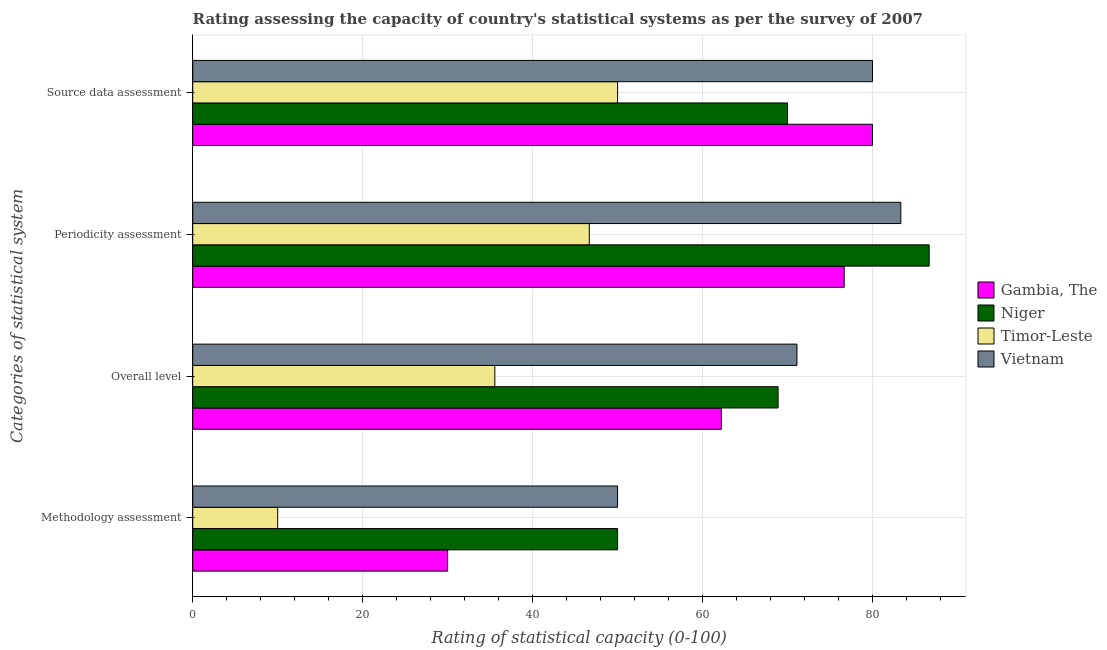How many groups of bars are there?
Your answer should be compact. 4. Are the number of bars per tick equal to the number of legend labels?
Make the answer very short. Yes. How many bars are there on the 2nd tick from the top?
Offer a terse response. 4. What is the label of the 4th group of bars from the top?
Offer a very short reply. Methodology assessment. What is the source data assessment rating in Gambia, The?
Make the answer very short. 80. Across all countries, what is the maximum source data assessment rating?
Keep it short and to the point. 80. Across all countries, what is the minimum periodicity assessment rating?
Your answer should be compact. 46.67. In which country was the methodology assessment rating maximum?
Make the answer very short. Niger. In which country was the methodology assessment rating minimum?
Your response must be concise. Timor-Leste. What is the total source data assessment rating in the graph?
Give a very brief answer. 280. What is the difference between the overall level rating in Vietnam and the source data assessment rating in Gambia, The?
Make the answer very short. -8.89. What is the average periodicity assessment rating per country?
Provide a succinct answer. 73.33. What is the difference between the periodicity assessment rating and methodology assessment rating in Vietnam?
Ensure brevity in your answer.  33.33. What is the ratio of the source data assessment rating in Niger to that in Gambia, The?
Your answer should be very brief. 0.88. Is the source data assessment rating in Vietnam less than that in Gambia, The?
Make the answer very short. No. What is the difference between the highest and the second highest methodology assessment rating?
Give a very brief answer. 0. What does the 1st bar from the top in Methodology assessment represents?
Keep it short and to the point. Vietnam. What does the 4th bar from the bottom in Overall level represents?
Make the answer very short. Vietnam. Is it the case that in every country, the sum of the methodology assessment rating and overall level rating is greater than the periodicity assessment rating?
Offer a terse response. No. Are all the bars in the graph horizontal?
Your answer should be very brief. Yes. How many countries are there in the graph?
Your answer should be compact. 4. What is the difference between two consecutive major ticks on the X-axis?
Your response must be concise. 20. Are the values on the major ticks of X-axis written in scientific E-notation?
Your answer should be very brief. No. Does the graph contain grids?
Offer a very short reply. Yes. How many legend labels are there?
Your answer should be very brief. 4. How are the legend labels stacked?
Offer a terse response. Vertical. What is the title of the graph?
Ensure brevity in your answer.  Rating assessing the capacity of country's statistical systems as per the survey of 2007 . What is the label or title of the X-axis?
Provide a succinct answer. Rating of statistical capacity (0-100). What is the label or title of the Y-axis?
Your response must be concise. Categories of statistical system. What is the Rating of statistical capacity (0-100) in Timor-Leste in Methodology assessment?
Offer a terse response. 10. What is the Rating of statistical capacity (0-100) in Gambia, The in Overall level?
Make the answer very short. 62.22. What is the Rating of statistical capacity (0-100) in Niger in Overall level?
Provide a short and direct response. 68.89. What is the Rating of statistical capacity (0-100) in Timor-Leste in Overall level?
Your answer should be compact. 35.56. What is the Rating of statistical capacity (0-100) in Vietnam in Overall level?
Give a very brief answer. 71.11. What is the Rating of statistical capacity (0-100) of Gambia, The in Periodicity assessment?
Your answer should be compact. 76.67. What is the Rating of statistical capacity (0-100) in Niger in Periodicity assessment?
Your answer should be compact. 86.67. What is the Rating of statistical capacity (0-100) of Timor-Leste in Periodicity assessment?
Offer a terse response. 46.67. What is the Rating of statistical capacity (0-100) in Vietnam in Periodicity assessment?
Your answer should be very brief. 83.33. What is the Rating of statistical capacity (0-100) in Gambia, The in Source data assessment?
Keep it short and to the point. 80. What is the Rating of statistical capacity (0-100) in Niger in Source data assessment?
Your answer should be very brief. 70. What is the Rating of statistical capacity (0-100) of Vietnam in Source data assessment?
Your answer should be compact. 80. Across all Categories of statistical system, what is the maximum Rating of statistical capacity (0-100) of Niger?
Make the answer very short. 86.67. Across all Categories of statistical system, what is the maximum Rating of statistical capacity (0-100) in Timor-Leste?
Provide a short and direct response. 50. Across all Categories of statistical system, what is the maximum Rating of statistical capacity (0-100) in Vietnam?
Give a very brief answer. 83.33. Across all Categories of statistical system, what is the minimum Rating of statistical capacity (0-100) in Gambia, The?
Offer a terse response. 30. Across all Categories of statistical system, what is the minimum Rating of statistical capacity (0-100) of Vietnam?
Offer a very short reply. 50. What is the total Rating of statistical capacity (0-100) in Gambia, The in the graph?
Make the answer very short. 248.89. What is the total Rating of statistical capacity (0-100) in Niger in the graph?
Your answer should be compact. 275.56. What is the total Rating of statistical capacity (0-100) of Timor-Leste in the graph?
Make the answer very short. 142.22. What is the total Rating of statistical capacity (0-100) in Vietnam in the graph?
Offer a very short reply. 284.44. What is the difference between the Rating of statistical capacity (0-100) in Gambia, The in Methodology assessment and that in Overall level?
Your answer should be compact. -32.22. What is the difference between the Rating of statistical capacity (0-100) of Niger in Methodology assessment and that in Overall level?
Keep it short and to the point. -18.89. What is the difference between the Rating of statistical capacity (0-100) in Timor-Leste in Methodology assessment and that in Overall level?
Your answer should be compact. -25.56. What is the difference between the Rating of statistical capacity (0-100) in Vietnam in Methodology assessment and that in Overall level?
Ensure brevity in your answer.  -21.11. What is the difference between the Rating of statistical capacity (0-100) in Gambia, The in Methodology assessment and that in Periodicity assessment?
Offer a very short reply. -46.67. What is the difference between the Rating of statistical capacity (0-100) in Niger in Methodology assessment and that in Periodicity assessment?
Ensure brevity in your answer.  -36.67. What is the difference between the Rating of statistical capacity (0-100) in Timor-Leste in Methodology assessment and that in Periodicity assessment?
Keep it short and to the point. -36.67. What is the difference between the Rating of statistical capacity (0-100) in Vietnam in Methodology assessment and that in Periodicity assessment?
Provide a short and direct response. -33.33. What is the difference between the Rating of statistical capacity (0-100) in Gambia, The in Methodology assessment and that in Source data assessment?
Provide a succinct answer. -50. What is the difference between the Rating of statistical capacity (0-100) in Timor-Leste in Methodology assessment and that in Source data assessment?
Give a very brief answer. -40. What is the difference between the Rating of statistical capacity (0-100) of Gambia, The in Overall level and that in Periodicity assessment?
Keep it short and to the point. -14.44. What is the difference between the Rating of statistical capacity (0-100) of Niger in Overall level and that in Periodicity assessment?
Provide a short and direct response. -17.78. What is the difference between the Rating of statistical capacity (0-100) in Timor-Leste in Overall level and that in Periodicity assessment?
Ensure brevity in your answer.  -11.11. What is the difference between the Rating of statistical capacity (0-100) of Vietnam in Overall level and that in Periodicity assessment?
Your answer should be very brief. -12.22. What is the difference between the Rating of statistical capacity (0-100) in Gambia, The in Overall level and that in Source data assessment?
Make the answer very short. -17.78. What is the difference between the Rating of statistical capacity (0-100) of Niger in Overall level and that in Source data assessment?
Give a very brief answer. -1.11. What is the difference between the Rating of statistical capacity (0-100) of Timor-Leste in Overall level and that in Source data assessment?
Your answer should be compact. -14.44. What is the difference between the Rating of statistical capacity (0-100) in Vietnam in Overall level and that in Source data assessment?
Keep it short and to the point. -8.89. What is the difference between the Rating of statistical capacity (0-100) in Niger in Periodicity assessment and that in Source data assessment?
Provide a short and direct response. 16.67. What is the difference between the Rating of statistical capacity (0-100) in Timor-Leste in Periodicity assessment and that in Source data assessment?
Provide a short and direct response. -3.33. What is the difference between the Rating of statistical capacity (0-100) of Vietnam in Periodicity assessment and that in Source data assessment?
Your answer should be very brief. 3.33. What is the difference between the Rating of statistical capacity (0-100) in Gambia, The in Methodology assessment and the Rating of statistical capacity (0-100) in Niger in Overall level?
Your answer should be compact. -38.89. What is the difference between the Rating of statistical capacity (0-100) of Gambia, The in Methodology assessment and the Rating of statistical capacity (0-100) of Timor-Leste in Overall level?
Offer a very short reply. -5.56. What is the difference between the Rating of statistical capacity (0-100) of Gambia, The in Methodology assessment and the Rating of statistical capacity (0-100) of Vietnam in Overall level?
Provide a succinct answer. -41.11. What is the difference between the Rating of statistical capacity (0-100) in Niger in Methodology assessment and the Rating of statistical capacity (0-100) in Timor-Leste in Overall level?
Provide a succinct answer. 14.44. What is the difference between the Rating of statistical capacity (0-100) of Niger in Methodology assessment and the Rating of statistical capacity (0-100) of Vietnam in Overall level?
Keep it short and to the point. -21.11. What is the difference between the Rating of statistical capacity (0-100) of Timor-Leste in Methodology assessment and the Rating of statistical capacity (0-100) of Vietnam in Overall level?
Provide a short and direct response. -61.11. What is the difference between the Rating of statistical capacity (0-100) in Gambia, The in Methodology assessment and the Rating of statistical capacity (0-100) in Niger in Periodicity assessment?
Ensure brevity in your answer.  -56.67. What is the difference between the Rating of statistical capacity (0-100) in Gambia, The in Methodology assessment and the Rating of statistical capacity (0-100) in Timor-Leste in Periodicity assessment?
Provide a short and direct response. -16.67. What is the difference between the Rating of statistical capacity (0-100) of Gambia, The in Methodology assessment and the Rating of statistical capacity (0-100) of Vietnam in Periodicity assessment?
Your response must be concise. -53.33. What is the difference between the Rating of statistical capacity (0-100) in Niger in Methodology assessment and the Rating of statistical capacity (0-100) in Timor-Leste in Periodicity assessment?
Make the answer very short. 3.33. What is the difference between the Rating of statistical capacity (0-100) in Niger in Methodology assessment and the Rating of statistical capacity (0-100) in Vietnam in Periodicity assessment?
Make the answer very short. -33.33. What is the difference between the Rating of statistical capacity (0-100) of Timor-Leste in Methodology assessment and the Rating of statistical capacity (0-100) of Vietnam in Periodicity assessment?
Offer a very short reply. -73.33. What is the difference between the Rating of statistical capacity (0-100) of Gambia, The in Methodology assessment and the Rating of statistical capacity (0-100) of Niger in Source data assessment?
Provide a short and direct response. -40. What is the difference between the Rating of statistical capacity (0-100) of Gambia, The in Methodology assessment and the Rating of statistical capacity (0-100) of Vietnam in Source data assessment?
Keep it short and to the point. -50. What is the difference between the Rating of statistical capacity (0-100) of Timor-Leste in Methodology assessment and the Rating of statistical capacity (0-100) of Vietnam in Source data assessment?
Make the answer very short. -70. What is the difference between the Rating of statistical capacity (0-100) of Gambia, The in Overall level and the Rating of statistical capacity (0-100) of Niger in Periodicity assessment?
Ensure brevity in your answer.  -24.44. What is the difference between the Rating of statistical capacity (0-100) in Gambia, The in Overall level and the Rating of statistical capacity (0-100) in Timor-Leste in Periodicity assessment?
Your response must be concise. 15.56. What is the difference between the Rating of statistical capacity (0-100) of Gambia, The in Overall level and the Rating of statistical capacity (0-100) of Vietnam in Periodicity assessment?
Provide a short and direct response. -21.11. What is the difference between the Rating of statistical capacity (0-100) of Niger in Overall level and the Rating of statistical capacity (0-100) of Timor-Leste in Periodicity assessment?
Offer a terse response. 22.22. What is the difference between the Rating of statistical capacity (0-100) in Niger in Overall level and the Rating of statistical capacity (0-100) in Vietnam in Periodicity assessment?
Give a very brief answer. -14.44. What is the difference between the Rating of statistical capacity (0-100) in Timor-Leste in Overall level and the Rating of statistical capacity (0-100) in Vietnam in Periodicity assessment?
Give a very brief answer. -47.78. What is the difference between the Rating of statistical capacity (0-100) of Gambia, The in Overall level and the Rating of statistical capacity (0-100) of Niger in Source data assessment?
Ensure brevity in your answer.  -7.78. What is the difference between the Rating of statistical capacity (0-100) of Gambia, The in Overall level and the Rating of statistical capacity (0-100) of Timor-Leste in Source data assessment?
Your answer should be compact. 12.22. What is the difference between the Rating of statistical capacity (0-100) of Gambia, The in Overall level and the Rating of statistical capacity (0-100) of Vietnam in Source data assessment?
Offer a terse response. -17.78. What is the difference between the Rating of statistical capacity (0-100) of Niger in Overall level and the Rating of statistical capacity (0-100) of Timor-Leste in Source data assessment?
Your answer should be very brief. 18.89. What is the difference between the Rating of statistical capacity (0-100) in Niger in Overall level and the Rating of statistical capacity (0-100) in Vietnam in Source data assessment?
Offer a very short reply. -11.11. What is the difference between the Rating of statistical capacity (0-100) of Timor-Leste in Overall level and the Rating of statistical capacity (0-100) of Vietnam in Source data assessment?
Your answer should be very brief. -44.44. What is the difference between the Rating of statistical capacity (0-100) in Gambia, The in Periodicity assessment and the Rating of statistical capacity (0-100) in Niger in Source data assessment?
Your response must be concise. 6.67. What is the difference between the Rating of statistical capacity (0-100) of Gambia, The in Periodicity assessment and the Rating of statistical capacity (0-100) of Timor-Leste in Source data assessment?
Ensure brevity in your answer.  26.67. What is the difference between the Rating of statistical capacity (0-100) of Gambia, The in Periodicity assessment and the Rating of statistical capacity (0-100) of Vietnam in Source data assessment?
Offer a terse response. -3.33. What is the difference between the Rating of statistical capacity (0-100) of Niger in Periodicity assessment and the Rating of statistical capacity (0-100) of Timor-Leste in Source data assessment?
Your response must be concise. 36.67. What is the difference between the Rating of statistical capacity (0-100) in Niger in Periodicity assessment and the Rating of statistical capacity (0-100) in Vietnam in Source data assessment?
Your answer should be compact. 6.67. What is the difference between the Rating of statistical capacity (0-100) of Timor-Leste in Periodicity assessment and the Rating of statistical capacity (0-100) of Vietnam in Source data assessment?
Your answer should be very brief. -33.33. What is the average Rating of statistical capacity (0-100) of Gambia, The per Categories of statistical system?
Offer a very short reply. 62.22. What is the average Rating of statistical capacity (0-100) in Niger per Categories of statistical system?
Your answer should be very brief. 68.89. What is the average Rating of statistical capacity (0-100) of Timor-Leste per Categories of statistical system?
Provide a succinct answer. 35.56. What is the average Rating of statistical capacity (0-100) in Vietnam per Categories of statistical system?
Offer a very short reply. 71.11. What is the difference between the Rating of statistical capacity (0-100) of Gambia, The and Rating of statistical capacity (0-100) of Niger in Methodology assessment?
Give a very brief answer. -20. What is the difference between the Rating of statistical capacity (0-100) in Gambia, The and Rating of statistical capacity (0-100) in Timor-Leste in Methodology assessment?
Provide a succinct answer. 20. What is the difference between the Rating of statistical capacity (0-100) of Niger and Rating of statistical capacity (0-100) of Timor-Leste in Methodology assessment?
Offer a very short reply. 40. What is the difference between the Rating of statistical capacity (0-100) of Timor-Leste and Rating of statistical capacity (0-100) of Vietnam in Methodology assessment?
Offer a terse response. -40. What is the difference between the Rating of statistical capacity (0-100) in Gambia, The and Rating of statistical capacity (0-100) in Niger in Overall level?
Keep it short and to the point. -6.67. What is the difference between the Rating of statistical capacity (0-100) in Gambia, The and Rating of statistical capacity (0-100) in Timor-Leste in Overall level?
Ensure brevity in your answer.  26.67. What is the difference between the Rating of statistical capacity (0-100) in Gambia, The and Rating of statistical capacity (0-100) in Vietnam in Overall level?
Your answer should be very brief. -8.89. What is the difference between the Rating of statistical capacity (0-100) of Niger and Rating of statistical capacity (0-100) of Timor-Leste in Overall level?
Offer a very short reply. 33.33. What is the difference between the Rating of statistical capacity (0-100) of Niger and Rating of statistical capacity (0-100) of Vietnam in Overall level?
Your answer should be compact. -2.22. What is the difference between the Rating of statistical capacity (0-100) of Timor-Leste and Rating of statistical capacity (0-100) of Vietnam in Overall level?
Provide a succinct answer. -35.56. What is the difference between the Rating of statistical capacity (0-100) in Gambia, The and Rating of statistical capacity (0-100) in Vietnam in Periodicity assessment?
Your answer should be compact. -6.67. What is the difference between the Rating of statistical capacity (0-100) in Niger and Rating of statistical capacity (0-100) in Timor-Leste in Periodicity assessment?
Give a very brief answer. 40. What is the difference between the Rating of statistical capacity (0-100) of Timor-Leste and Rating of statistical capacity (0-100) of Vietnam in Periodicity assessment?
Offer a very short reply. -36.67. What is the difference between the Rating of statistical capacity (0-100) of Gambia, The and Rating of statistical capacity (0-100) of Timor-Leste in Source data assessment?
Keep it short and to the point. 30. What is the difference between the Rating of statistical capacity (0-100) in Niger and Rating of statistical capacity (0-100) in Timor-Leste in Source data assessment?
Give a very brief answer. 20. What is the ratio of the Rating of statistical capacity (0-100) in Gambia, The in Methodology assessment to that in Overall level?
Your response must be concise. 0.48. What is the ratio of the Rating of statistical capacity (0-100) in Niger in Methodology assessment to that in Overall level?
Your answer should be very brief. 0.73. What is the ratio of the Rating of statistical capacity (0-100) in Timor-Leste in Methodology assessment to that in Overall level?
Your answer should be very brief. 0.28. What is the ratio of the Rating of statistical capacity (0-100) in Vietnam in Methodology assessment to that in Overall level?
Provide a succinct answer. 0.7. What is the ratio of the Rating of statistical capacity (0-100) of Gambia, The in Methodology assessment to that in Periodicity assessment?
Ensure brevity in your answer.  0.39. What is the ratio of the Rating of statistical capacity (0-100) in Niger in Methodology assessment to that in Periodicity assessment?
Offer a terse response. 0.58. What is the ratio of the Rating of statistical capacity (0-100) of Timor-Leste in Methodology assessment to that in Periodicity assessment?
Your answer should be very brief. 0.21. What is the ratio of the Rating of statistical capacity (0-100) of Niger in Methodology assessment to that in Source data assessment?
Give a very brief answer. 0.71. What is the ratio of the Rating of statistical capacity (0-100) in Gambia, The in Overall level to that in Periodicity assessment?
Keep it short and to the point. 0.81. What is the ratio of the Rating of statistical capacity (0-100) of Niger in Overall level to that in Periodicity assessment?
Your answer should be compact. 0.79. What is the ratio of the Rating of statistical capacity (0-100) in Timor-Leste in Overall level to that in Periodicity assessment?
Provide a succinct answer. 0.76. What is the ratio of the Rating of statistical capacity (0-100) in Vietnam in Overall level to that in Periodicity assessment?
Make the answer very short. 0.85. What is the ratio of the Rating of statistical capacity (0-100) in Niger in Overall level to that in Source data assessment?
Provide a succinct answer. 0.98. What is the ratio of the Rating of statistical capacity (0-100) of Timor-Leste in Overall level to that in Source data assessment?
Provide a short and direct response. 0.71. What is the ratio of the Rating of statistical capacity (0-100) of Vietnam in Overall level to that in Source data assessment?
Your answer should be compact. 0.89. What is the ratio of the Rating of statistical capacity (0-100) in Gambia, The in Periodicity assessment to that in Source data assessment?
Ensure brevity in your answer.  0.96. What is the ratio of the Rating of statistical capacity (0-100) in Niger in Periodicity assessment to that in Source data assessment?
Your response must be concise. 1.24. What is the ratio of the Rating of statistical capacity (0-100) in Vietnam in Periodicity assessment to that in Source data assessment?
Your answer should be very brief. 1.04. What is the difference between the highest and the second highest Rating of statistical capacity (0-100) in Niger?
Your answer should be very brief. 16.67. What is the difference between the highest and the second highest Rating of statistical capacity (0-100) of Timor-Leste?
Your response must be concise. 3.33. What is the difference between the highest and the second highest Rating of statistical capacity (0-100) in Vietnam?
Keep it short and to the point. 3.33. What is the difference between the highest and the lowest Rating of statistical capacity (0-100) in Gambia, The?
Keep it short and to the point. 50. What is the difference between the highest and the lowest Rating of statistical capacity (0-100) of Niger?
Provide a succinct answer. 36.67. What is the difference between the highest and the lowest Rating of statistical capacity (0-100) of Vietnam?
Your answer should be compact. 33.33. 